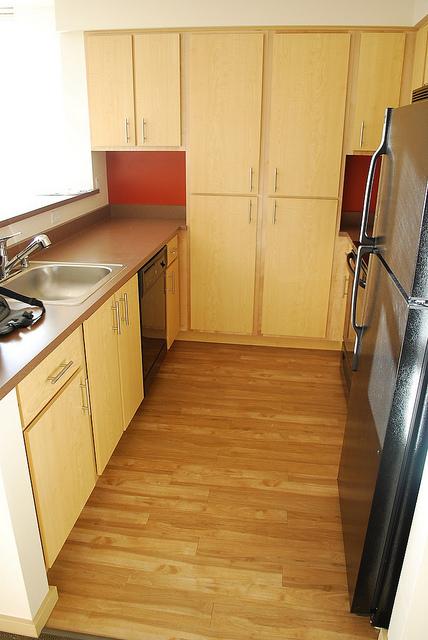Where in the house is this room?
Short answer required. Kitchen. What is the refrigerator made of?
Short answer required. Metal. What is the flooring made of?
Keep it brief. Wood. 